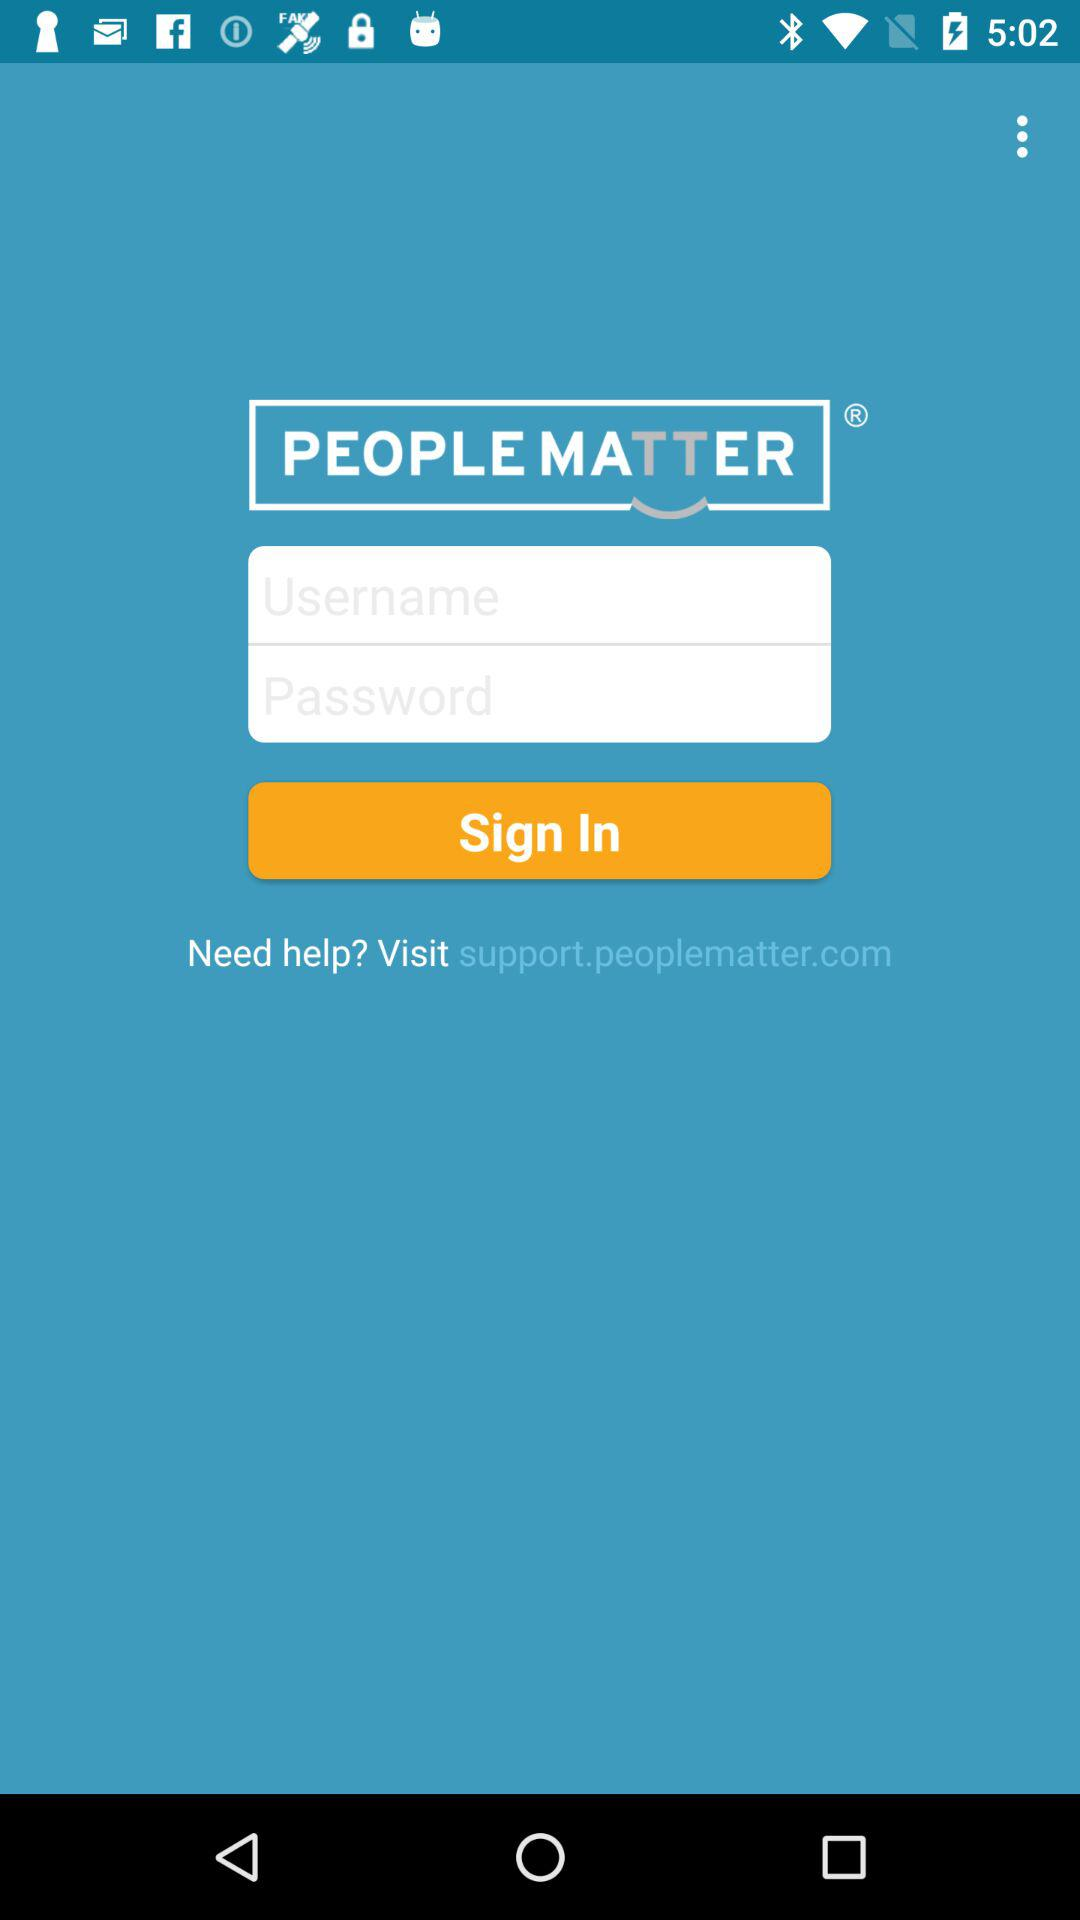What website can I visit for any support and help? You can visit support.peoplematter.com for any support and help. 